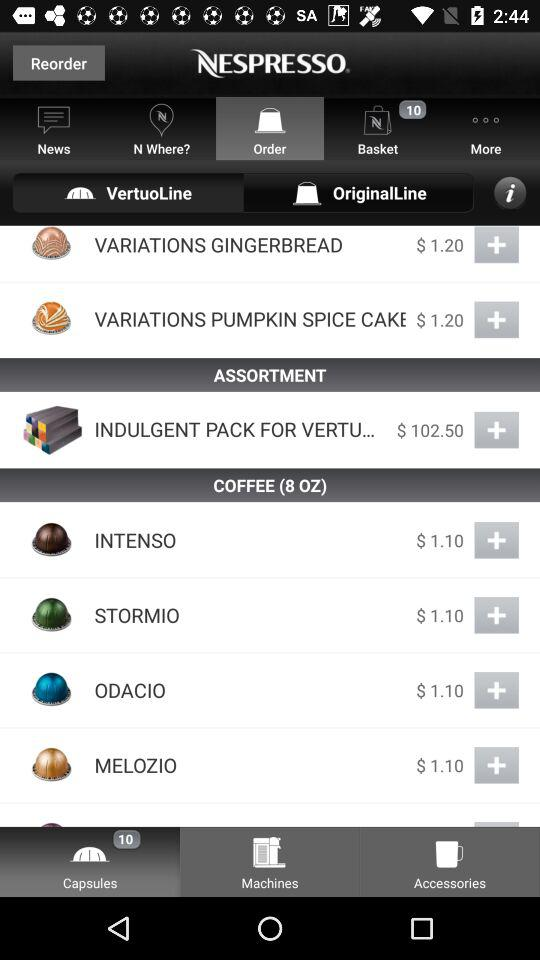What is the price of the "INDULGENT PACK"? The price of the "INDULGENT PACK" is $102.50. 